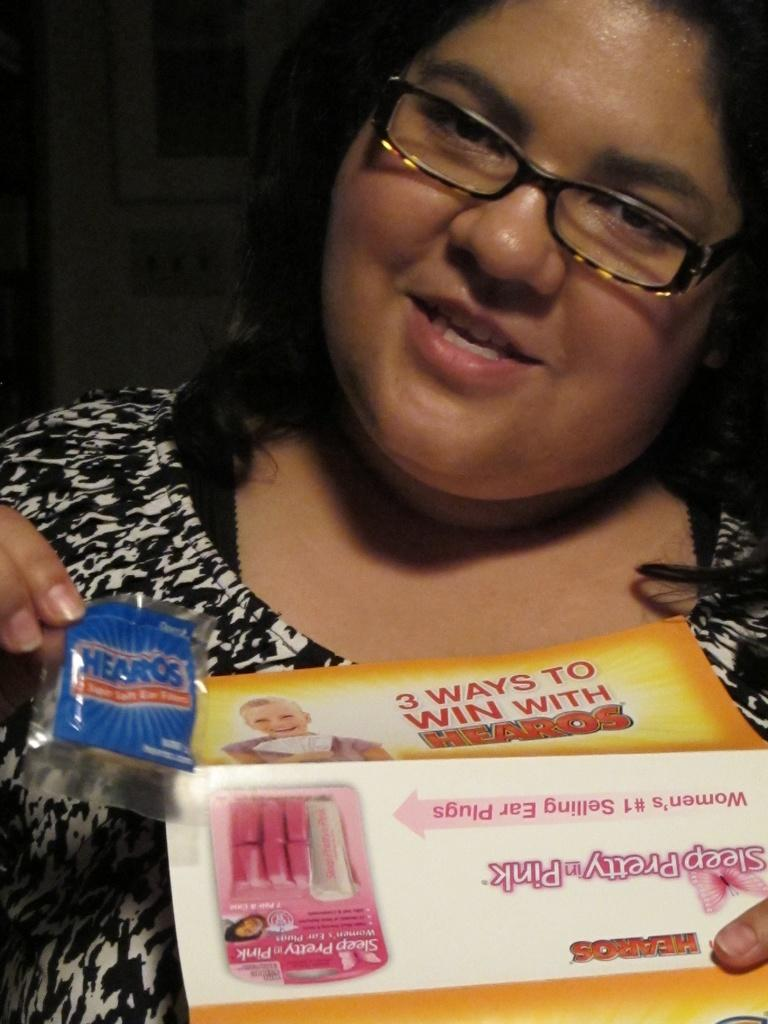Who is the main subject in the image? There is a woman in the image. What can be seen on the woman's face? The woman is wearing glasses (specs). What is the woman holding in her hand? The woman is holding a small packet and a book. What type of substance is the woman using to read the book in the image? There is no substance visible in the image that the woman is using to read the book. 